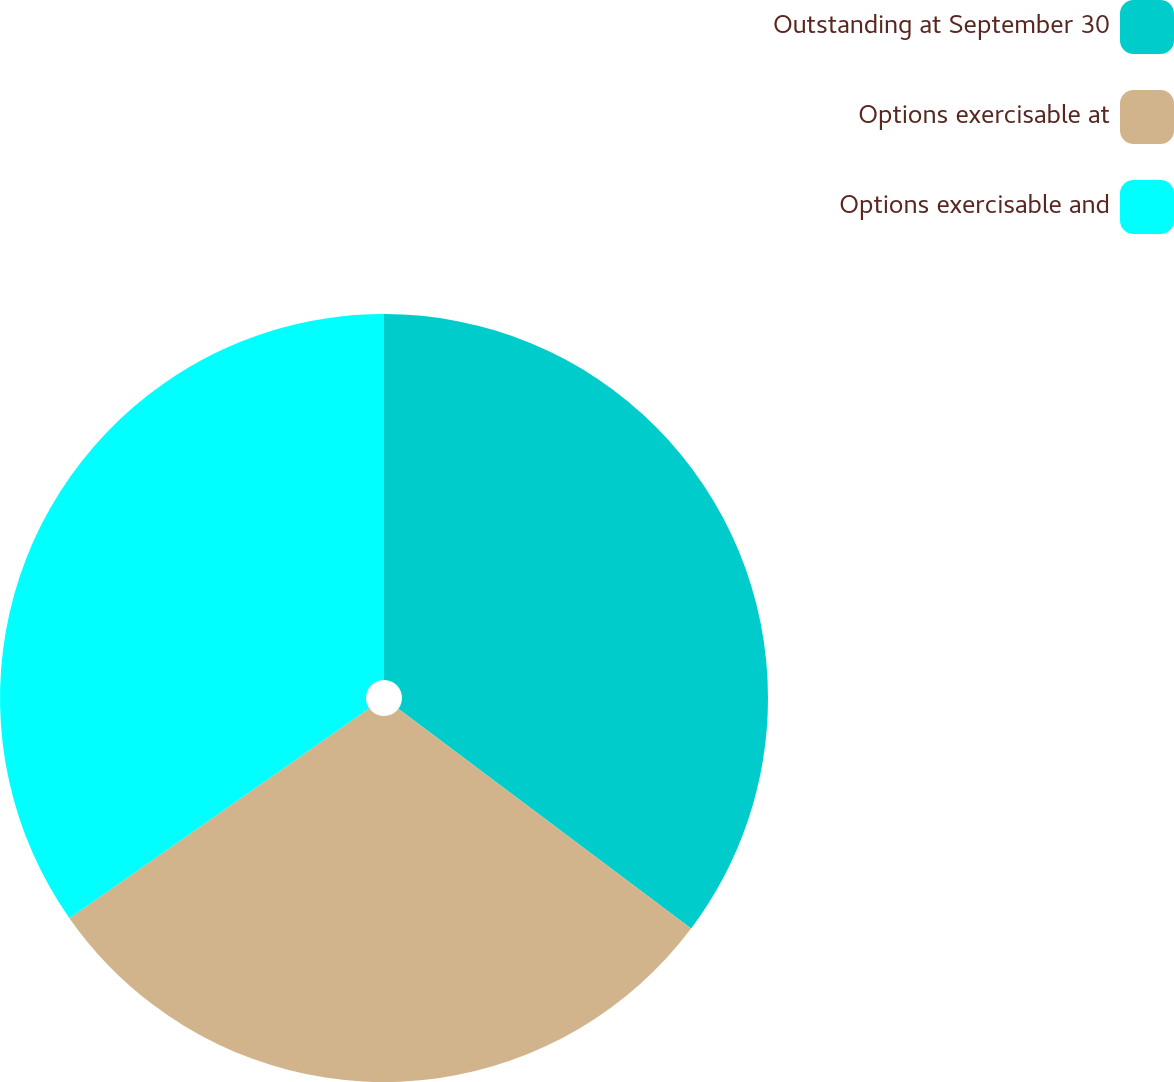Convert chart. <chart><loc_0><loc_0><loc_500><loc_500><pie_chart><fcel>Outstanding at September 30<fcel>Options exercisable at<fcel>Options exercisable and<nl><fcel>35.25%<fcel>30.03%<fcel>34.72%<nl></chart> 